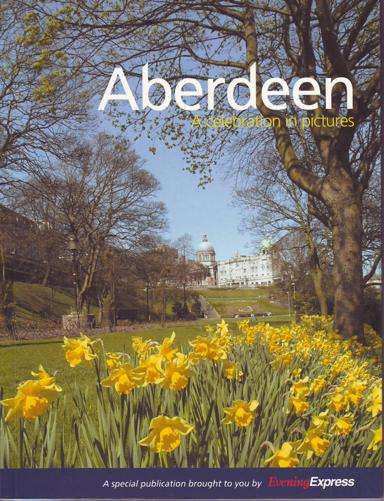How might this publication contribute to local tourism? This special publication, 'Aberdeen: A Celebration in Pictures,' could significantly contribute to local tourism by showcasing the unique beauty and cultural significance of Aberdeen. By featuring captivating images and possibly interesting narratives about key landmarks and local history, it serves as an enticing visual invitation for tourists to explore the city more fully. 